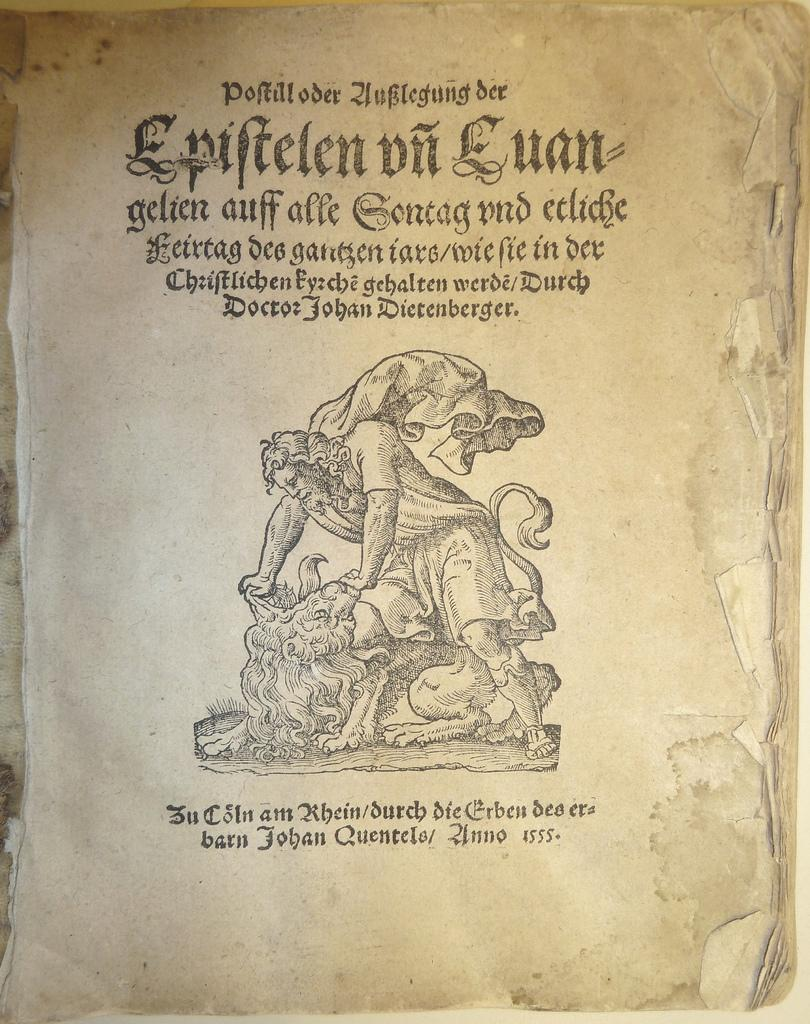<image>
Give a short and clear explanation of the subsequent image. The literature here is written in non English in the year 1555 